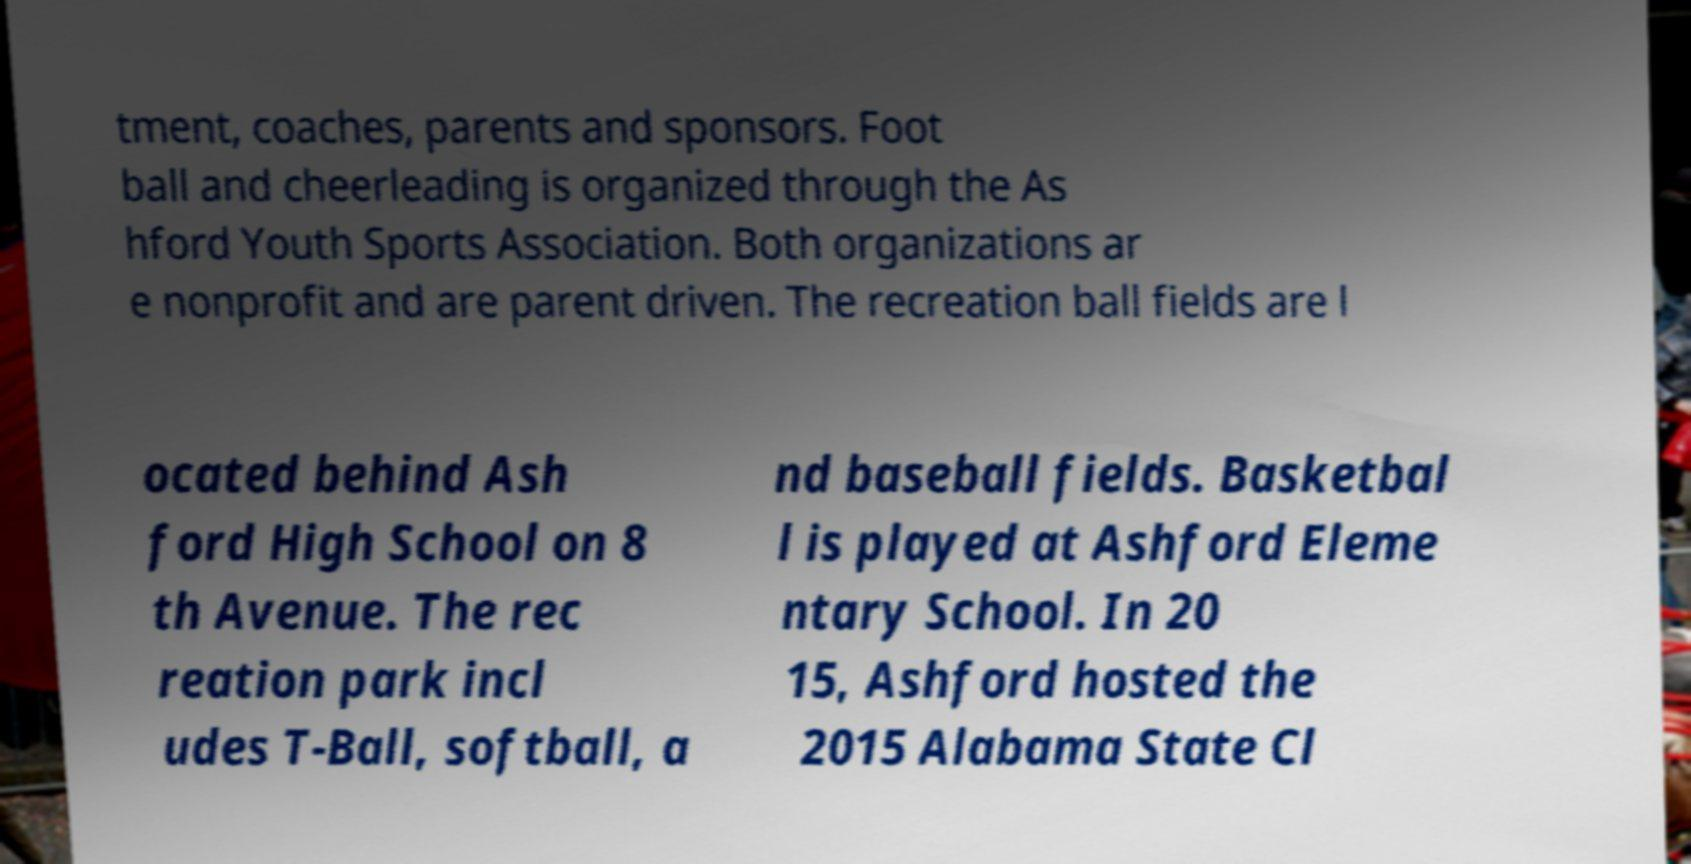For documentation purposes, I need the text within this image transcribed. Could you provide that? tment, coaches, parents and sponsors. Foot ball and cheerleading is organized through the As hford Youth Sports Association. Both organizations ar e nonprofit and are parent driven. The recreation ball fields are l ocated behind Ash ford High School on 8 th Avenue. The rec reation park incl udes T-Ball, softball, a nd baseball fields. Basketbal l is played at Ashford Eleme ntary School. In 20 15, Ashford hosted the 2015 Alabama State Cl 